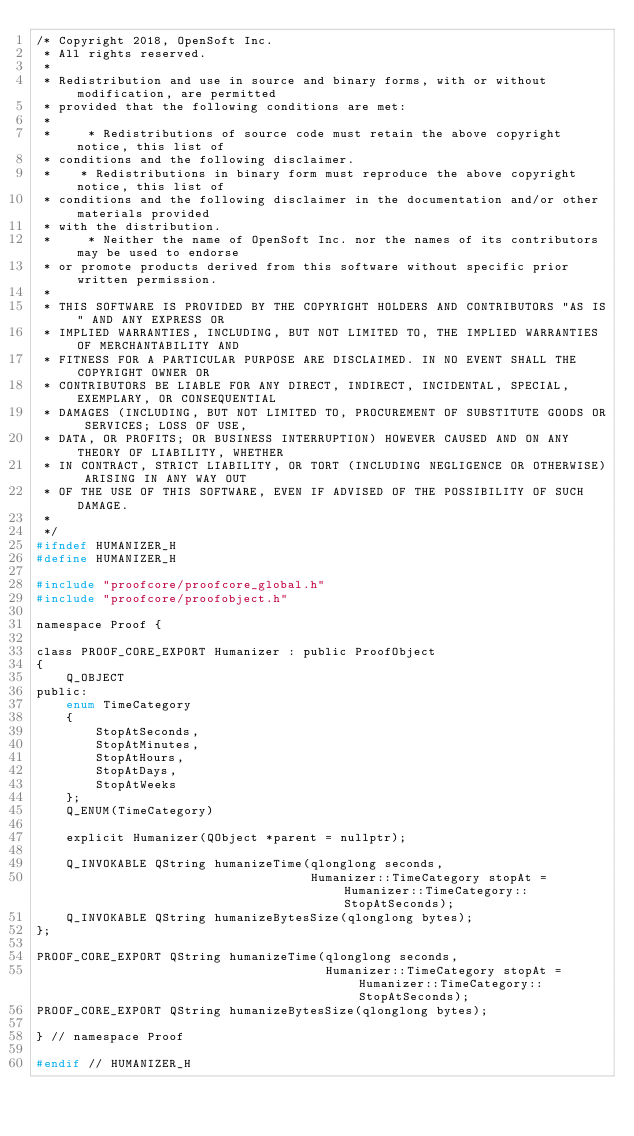Convert code to text. <code><loc_0><loc_0><loc_500><loc_500><_C_>/* Copyright 2018, OpenSoft Inc.
 * All rights reserved.
 *
 * Redistribution and use in source and binary forms, with or without modification, are permitted
 * provided that the following conditions are met:
 *
 *     * Redistributions of source code must retain the above copyright notice, this list of
 * conditions and the following disclaimer.
 *    * Redistributions in binary form must reproduce the above copyright notice, this list of
 * conditions and the following disclaimer in the documentation and/or other materials provided
 * with the distribution.
 *     * Neither the name of OpenSoft Inc. nor the names of its contributors may be used to endorse
 * or promote products derived from this software without specific prior written permission.
 *
 * THIS SOFTWARE IS PROVIDED BY THE COPYRIGHT HOLDERS AND CONTRIBUTORS "AS IS" AND ANY EXPRESS OR
 * IMPLIED WARRANTIES, INCLUDING, BUT NOT LIMITED TO, THE IMPLIED WARRANTIES OF MERCHANTABILITY AND
 * FITNESS FOR A PARTICULAR PURPOSE ARE DISCLAIMED. IN NO EVENT SHALL THE COPYRIGHT OWNER OR
 * CONTRIBUTORS BE LIABLE FOR ANY DIRECT, INDIRECT, INCIDENTAL, SPECIAL, EXEMPLARY, OR CONSEQUENTIAL
 * DAMAGES (INCLUDING, BUT NOT LIMITED TO, PROCUREMENT OF SUBSTITUTE GOODS OR SERVICES; LOSS OF USE,
 * DATA, OR PROFITS; OR BUSINESS INTERRUPTION) HOWEVER CAUSED AND ON ANY THEORY OF LIABILITY, WHETHER
 * IN CONTRACT, STRICT LIABILITY, OR TORT (INCLUDING NEGLIGENCE OR OTHERWISE) ARISING IN ANY WAY OUT
 * OF THE USE OF THIS SOFTWARE, EVEN IF ADVISED OF THE POSSIBILITY OF SUCH DAMAGE.
 *
 */
#ifndef HUMANIZER_H
#define HUMANIZER_H

#include "proofcore/proofcore_global.h"
#include "proofcore/proofobject.h"

namespace Proof {

class PROOF_CORE_EXPORT Humanizer : public ProofObject
{
    Q_OBJECT
public:
    enum TimeCategory
    {
        StopAtSeconds,
        StopAtMinutes,
        StopAtHours,
        StopAtDays,
        StopAtWeeks
    };
    Q_ENUM(TimeCategory)

    explicit Humanizer(QObject *parent = nullptr);

    Q_INVOKABLE QString humanizeTime(qlonglong seconds,
                                     Humanizer::TimeCategory stopAt = Humanizer::TimeCategory::StopAtSeconds);
    Q_INVOKABLE QString humanizeBytesSize(qlonglong bytes);
};

PROOF_CORE_EXPORT QString humanizeTime(qlonglong seconds,
                                       Humanizer::TimeCategory stopAt = Humanizer::TimeCategory::StopAtSeconds);
PROOF_CORE_EXPORT QString humanizeBytesSize(qlonglong bytes);

} // namespace Proof

#endif // HUMANIZER_H
</code> 